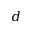<formula> <loc_0><loc_0><loc_500><loc_500>d</formula> 